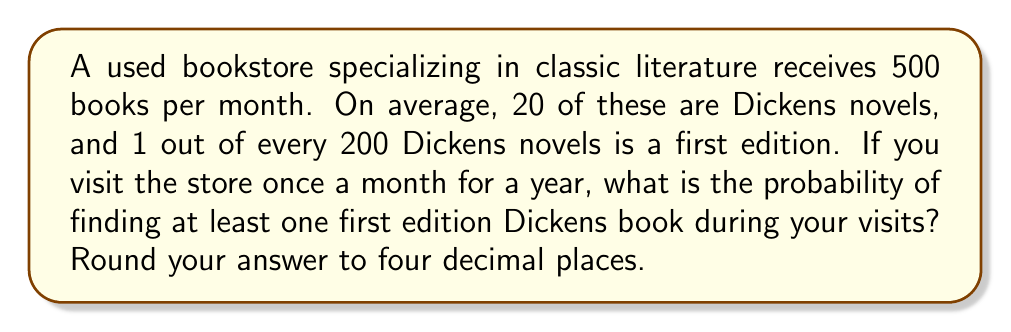Can you solve this math problem? Let's approach this step-by-step:

1. First, let's calculate the probability of finding a first edition Dickens book in a single month:

   - Number of Dickens books per month: 20
   - Probability of a Dickens book being a first edition: 1/200
   - Expected number of first edition Dickens books per month: $20 * (1/200) = 0.1$

   Probability of finding at least one first edition in a month:
   $p = 1 - P(\text{no first editions}) = 1 - (1 - 0.1/20)^{20} \approx 0.0952$

2. Now, we need to calculate the probability of finding at least one first edition over 12 months.

3. This is equivalent to the probability of not failing to find a first edition for all 12 months:

   $P(\text{at least one in 12 months}) = 1 - P(\text{none in 12 months})$

4. The probability of finding no first editions in 12 months is:

   $P(\text{none in 12 months}) = (1 - p)^{12}$

5. Therefore, the probability of finding at least one first edition in 12 months is:

   $P(\text{at least one in 12 months}) = 1 - (1 - p)^{12}$

6. Substituting our value for $p$:

   $P(\text{at least one in 12 months}) = 1 - (1 - 0.0952)^{12} \approx 0.7104$

7. Rounding to four decimal places: 0.7104
Answer: 0.7104 